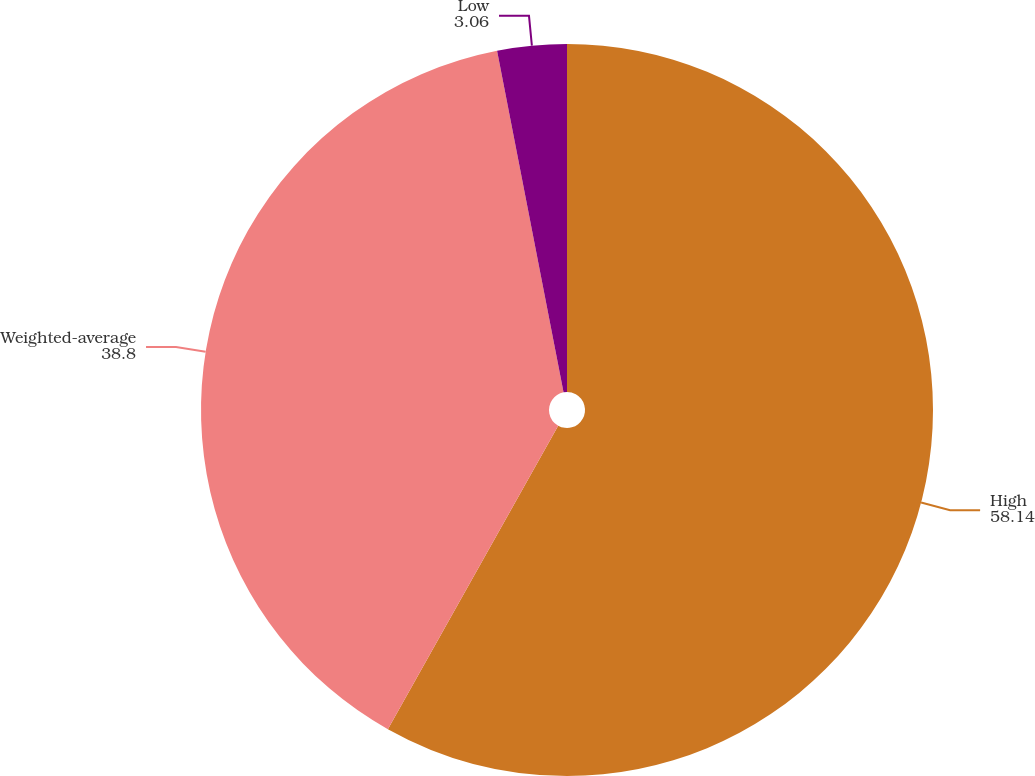Convert chart to OTSL. <chart><loc_0><loc_0><loc_500><loc_500><pie_chart><fcel>High<fcel>Weighted-average<fcel>Low<nl><fcel>58.14%<fcel>38.8%<fcel>3.06%<nl></chart> 